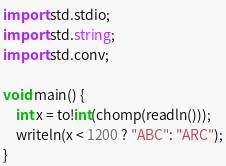Convert code to text. <code><loc_0><loc_0><loc_500><loc_500><_D_>import std.stdio;
import std.string;
import std.conv;

void main() {
	int x = to!int(chomp(readln()));
	writeln(x < 1200 ? "ABC": "ARC");
}
</code> 